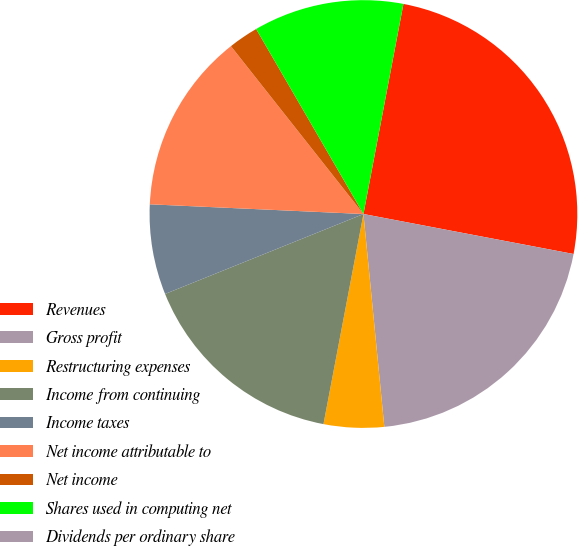Convert chart. <chart><loc_0><loc_0><loc_500><loc_500><pie_chart><fcel>Revenues<fcel>Gross profit<fcel>Restructuring expenses<fcel>Income from continuing<fcel>Income taxes<fcel>Net income attributable to<fcel>Net income<fcel>Shares used in computing net<fcel>Dividends per ordinary share<nl><fcel>25.0%<fcel>20.45%<fcel>4.55%<fcel>15.91%<fcel>6.82%<fcel>13.64%<fcel>2.27%<fcel>11.36%<fcel>0.0%<nl></chart> 